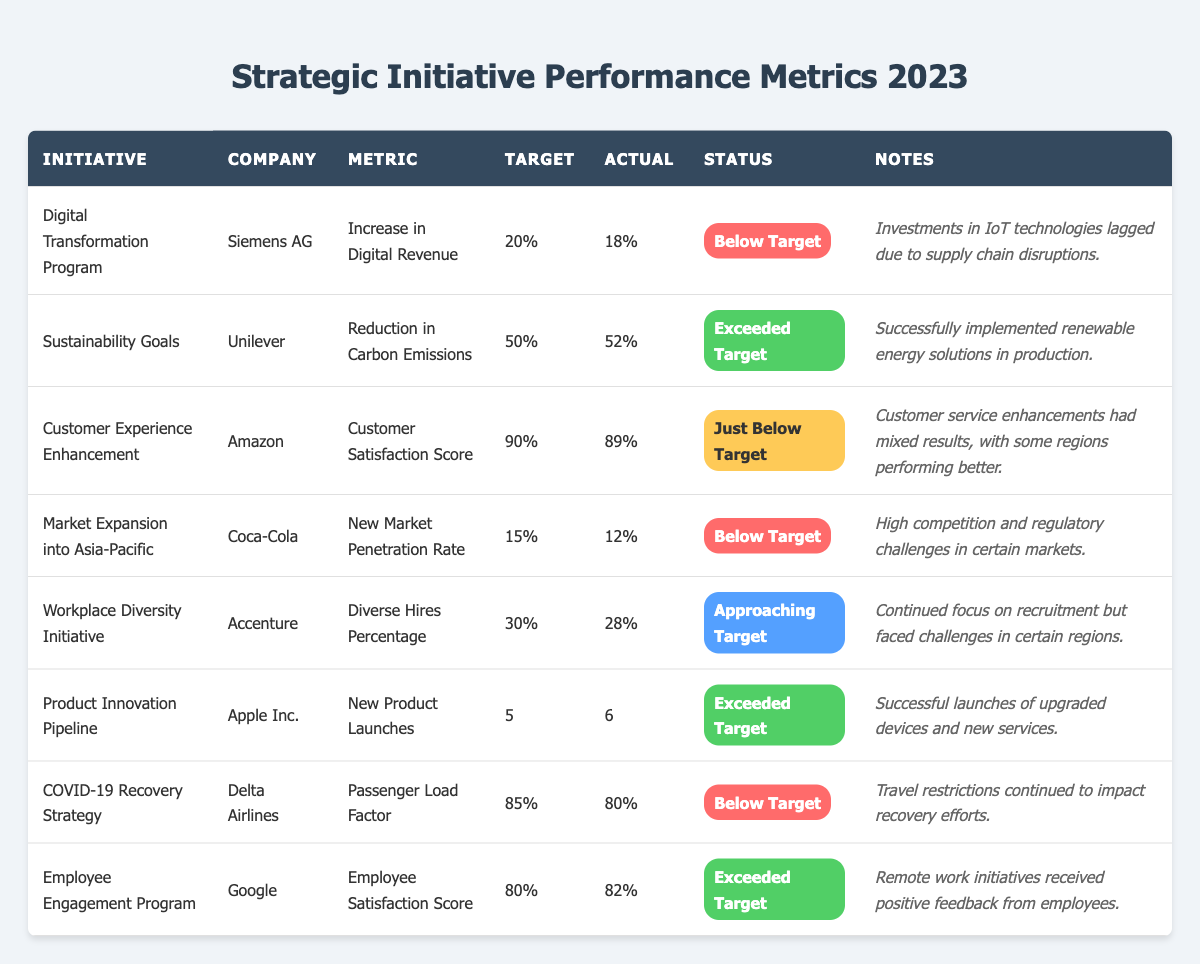What is the actual percentage of reduction in carbon emissions achieved by Unilever? The table shows that Unilever's actual reduction in carbon emissions is 52%.
Answer: 52% Which company exceeded its target for the number of new product launches? The table indicates that Apple Inc. exceeded its target by achieving 6 new product launches against a target of 5.
Answer: Apple Inc What is the target for the Customer Satisfaction Score for Amazon? According to the table, the target for Amazon's Customer Satisfaction Score is 90%.
Answer: 90% How many initiatives are listed in the table that are below target? By reviewing the table, we can see that there are four initiatives (Digital Transformation Program, Market Expansion into Asia-Pacific, COVID-19 Recovery Strategy, and Customer Experience Enhancement) marked as below target.
Answer: 4 Is the Employee Satisfaction Score for Google above or below target? The table shows that Google's actual Employee Satisfaction Score is 82%, which is above the target of 80%.
Answer: Above What is the difference between the target and actual percentage for Siemens AG's Digital Revenue increase? Siemens AG had a target of 20% and an actual of 18%, so the difference is 20% - 18% = 2%.
Answer: 2% How many initiatives are approaching their targets? The table lists one initiative (Workplace Diversity Initiative) that is approaching its target with an actual of 28% against a target of 30%.
Answer: 1 Among the companies listed, which one has faced challenges specifically due to high competition and regulatory issues? The table indicates Coca-Cola faced such challenges in its Market Expansion into the Asia-Pacific initiative.
Answer: Coca-Cola What is the average actual percentage for all initiatives listed in the table? To find the average, sum the actual values: (18 + 52 + 89 + 12 + 28 + 6 + 80 + 82) = 367 and divide by 8 initiatives: 367 / 8 = 45.875%.
Answer: 45.875% Which initiative had the highest actual score relative to its target? The Employee Engagement Program by Google had an actual score of 82% against a target of 80%, resulting in a positive deviation of 2%.
Answer: Employee Engagement Program 